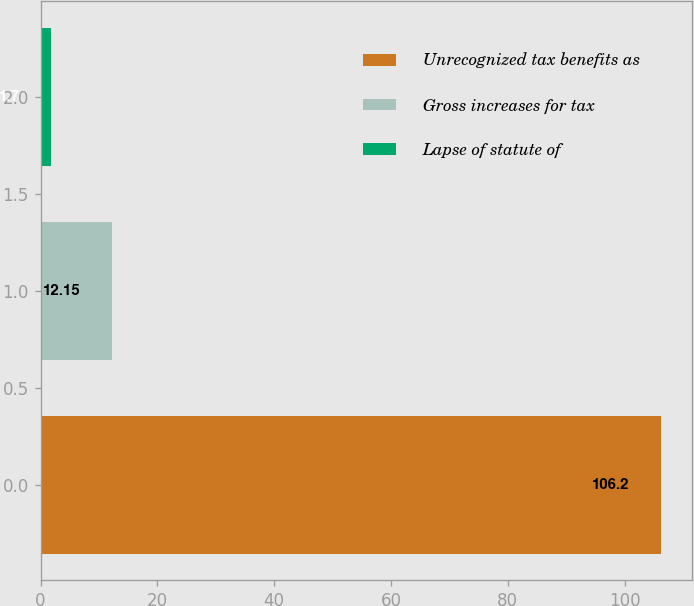Convert chart to OTSL. <chart><loc_0><loc_0><loc_500><loc_500><bar_chart><fcel>Unrecognized tax benefits as<fcel>Gross increases for tax<fcel>Lapse of statute of<nl><fcel>106.2<fcel>12.15<fcel>1.7<nl></chart> 